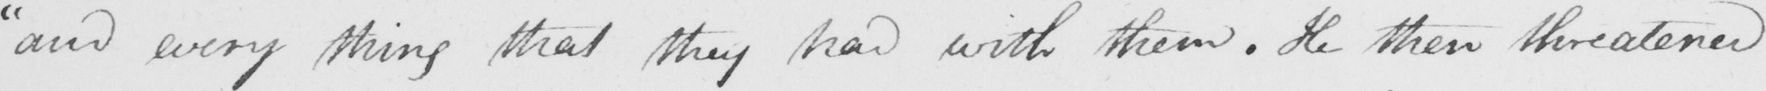Please transcribe the handwritten text in this image. " and every thing that they had with them . He threatened 